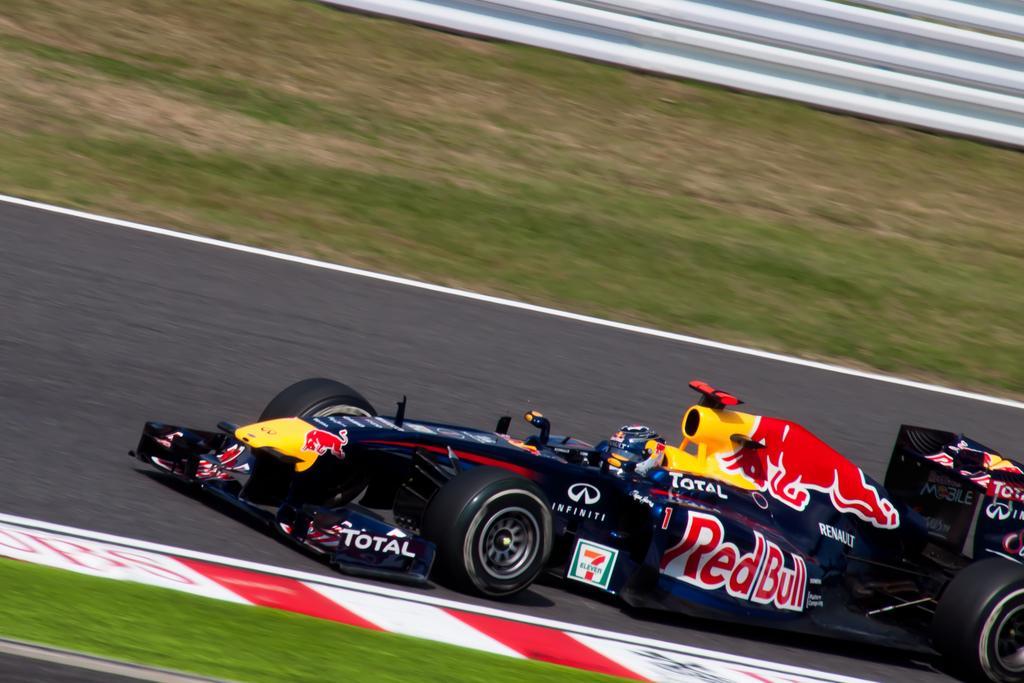In one or two sentences, can you explain what this image depicts? It's a racing car which is in black color on the road. 